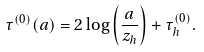Convert formula to latex. <formula><loc_0><loc_0><loc_500><loc_500>\tau ^ { ( 0 ) } ( a ) = 2 \log \left ( \frac { a } { z _ { h } } \right ) + \tau ^ { ( 0 ) } _ { h } .</formula> 